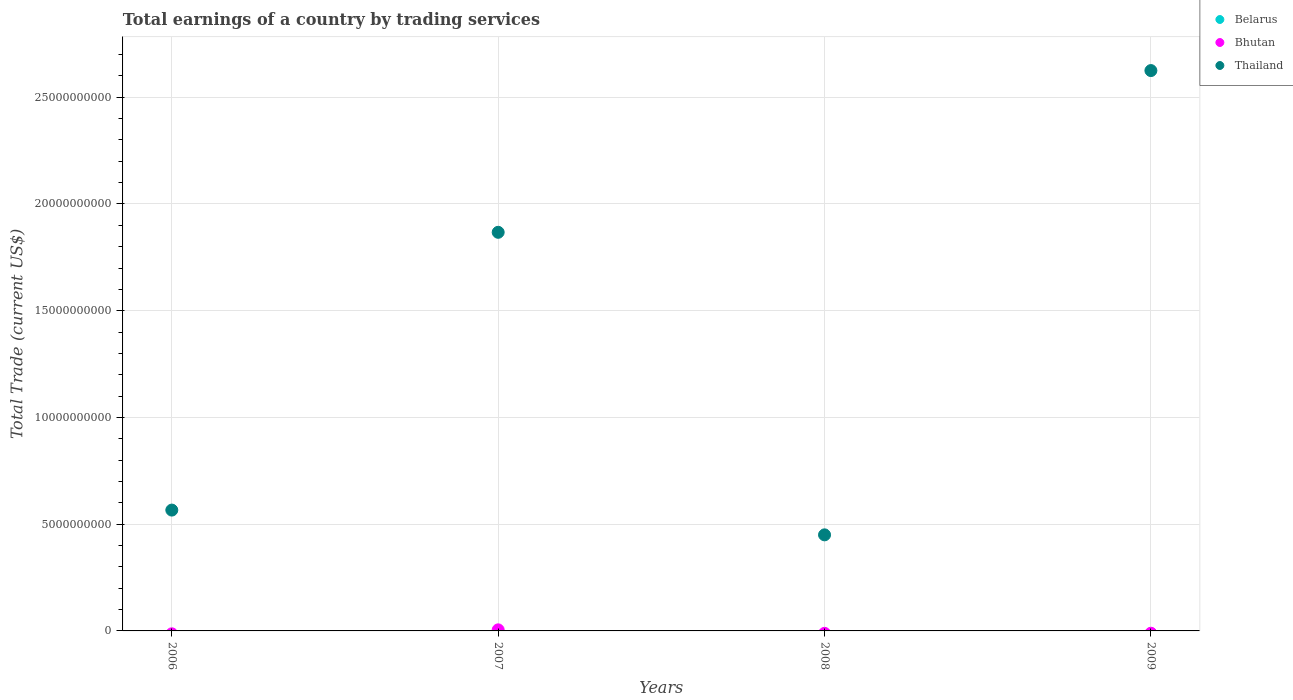How many different coloured dotlines are there?
Give a very brief answer. 2. Is the number of dotlines equal to the number of legend labels?
Keep it short and to the point. No. Across all years, what is the maximum total earnings in Thailand?
Offer a very short reply. 2.62e+1. Across all years, what is the minimum total earnings in Thailand?
Provide a short and direct response. 4.50e+09. In which year was the total earnings in Bhutan maximum?
Make the answer very short. 2007. What is the total total earnings in Bhutan in the graph?
Your response must be concise. 5.04e+07. What is the difference between the total earnings in Thailand in 2008 and that in 2009?
Offer a terse response. -2.17e+1. What is the difference between the total earnings in Belarus in 2006 and the total earnings in Bhutan in 2008?
Your answer should be very brief. 0. What is the average total earnings in Belarus per year?
Provide a succinct answer. 0. In the year 2007, what is the difference between the total earnings in Bhutan and total earnings in Thailand?
Keep it short and to the point. -1.86e+1. What is the ratio of the total earnings in Thailand in 2006 to that in 2008?
Ensure brevity in your answer.  1.26. Is the total earnings in Thailand in 2006 less than that in 2007?
Offer a very short reply. Yes. What is the difference between the highest and the second highest total earnings in Thailand?
Your response must be concise. 7.58e+09. What is the difference between the highest and the lowest total earnings in Thailand?
Give a very brief answer. 2.17e+1. Is the total earnings in Bhutan strictly greater than the total earnings in Thailand over the years?
Keep it short and to the point. No. Is the total earnings in Belarus strictly less than the total earnings in Thailand over the years?
Provide a succinct answer. Yes. How many dotlines are there?
Offer a terse response. 2. How many years are there in the graph?
Make the answer very short. 4. What is the difference between two consecutive major ticks on the Y-axis?
Offer a terse response. 5.00e+09. Are the values on the major ticks of Y-axis written in scientific E-notation?
Provide a short and direct response. No. Does the graph contain any zero values?
Your answer should be compact. Yes. Does the graph contain grids?
Give a very brief answer. Yes. How many legend labels are there?
Provide a short and direct response. 3. How are the legend labels stacked?
Provide a succinct answer. Vertical. What is the title of the graph?
Make the answer very short. Total earnings of a country by trading services. Does "South Sudan" appear as one of the legend labels in the graph?
Offer a terse response. No. What is the label or title of the Y-axis?
Your answer should be compact. Total Trade (current US$). What is the Total Trade (current US$) in Belarus in 2006?
Offer a very short reply. 0. What is the Total Trade (current US$) in Bhutan in 2006?
Ensure brevity in your answer.  0. What is the Total Trade (current US$) in Thailand in 2006?
Ensure brevity in your answer.  5.66e+09. What is the Total Trade (current US$) of Belarus in 2007?
Ensure brevity in your answer.  0. What is the Total Trade (current US$) of Bhutan in 2007?
Give a very brief answer. 5.04e+07. What is the Total Trade (current US$) of Thailand in 2007?
Ensure brevity in your answer.  1.87e+1. What is the Total Trade (current US$) of Belarus in 2008?
Give a very brief answer. 0. What is the Total Trade (current US$) in Thailand in 2008?
Offer a very short reply. 4.50e+09. What is the Total Trade (current US$) in Thailand in 2009?
Your response must be concise. 2.62e+1. Across all years, what is the maximum Total Trade (current US$) of Bhutan?
Your answer should be very brief. 5.04e+07. Across all years, what is the maximum Total Trade (current US$) of Thailand?
Offer a terse response. 2.62e+1. Across all years, what is the minimum Total Trade (current US$) in Bhutan?
Keep it short and to the point. 0. Across all years, what is the minimum Total Trade (current US$) in Thailand?
Make the answer very short. 4.50e+09. What is the total Total Trade (current US$) in Belarus in the graph?
Make the answer very short. 0. What is the total Total Trade (current US$) of Bhutan in the graph?
Ensure brevity in your answer.  5.04e+07. What is the total Total Trade (current US$) of Thailand in the graph?
Give a very brief answer. 5.51e+1. What is the difference between the Total Trade (current US$) in Thailand in 2006 and that in 2007?
Your response must be concise. -1.30e+1. What is the difference between the Total Trade (current US$) of Thailand in 2006 and that in 2008?
Provide a succinct answer. 1.16e+09. What is the difference between the Total Trade (current US$) of Thailand in 2006 and that in 2009?
Offer a very short reply. -2.06e+1. What is the difference between the Total Trade (current US$) in Thailand in 2007 and that in 2008?
Provide a succinct answer. 1.42e+1. What is the difference between the Total Trade (current US$) in Thailand in 2007 and that in 2009?
Your answer should be very brief. -7.58e+09. What is the difference between the Total Trade (current US$) in Thailand in 2008 and that in 2009?
Make the answer very short. -2.17e+1. What is the difference between the Total Trade (current US$) of Bhutan in 2007 and the Total Trade (current US$) of Thailand in 2008?
Your answer should be compact. -4.45e+09. What is the difference between the Total Trade (current US$) in Bhutan in 2007 and the Total Trade (current US$) in Thailand in 2009?
Your answer should be compact. -2.62e+1. What is the average Total Trade (current US$) of Belarus per year?
Give a very brief answer. 0. What is the average Total Trade (current US$) of Bhutan per year?
Provide a succinct answer. 1.26e+07. What is the average Total Trade (current US$) in Thailand per year?
Your answer should be compact. 1.38e+1. In the year 2007, what is the difference between the Total Trade (current US$) of Bhutan and Total Trade (current US$) of Thailand?
Give a very brief answer. -1.86e+1. What is the ratio of the Total Trade (current US$) of Thailand in 2006 to that in 2007?
Your response must be concise. 0.3. What is the ratio of the Total Trade (current US$) of Thailand in 2006 to that in 2008?
Give a very brief answer. 1.26. What is the ratio of the Total Trade (current US$) in Thailand in 2006 to that in 2009?
Your answer should be compact. 0.22. What is the ratio of the Total Trade (current US$) of Thailand in 2007 to that in 2008?
Make the answer very short. 4.15. What is the ratio of the Total Trade (current US$) of Thailand in 2007 to that in 2009?
Make the answer very short. 0.71. What is the ratio of the Total Trade (current US$) in Thailand in 2008 to that in 2009?
Your answer should be compact. 0.17. What is the difference between the highest and the second highest Total Trade (current US$) in Thailand?
Ensure brevity in your answer.  7.58e+09. What is the difference between the highest and the lowest Total Trade (current US$) of Bhutan?
Give a very brief answer. 5.04e+07. What is the difference between the highest and the lowest Total Trade (current US$) in Thailand?
Your answer should be compact. 2.17e+1. 